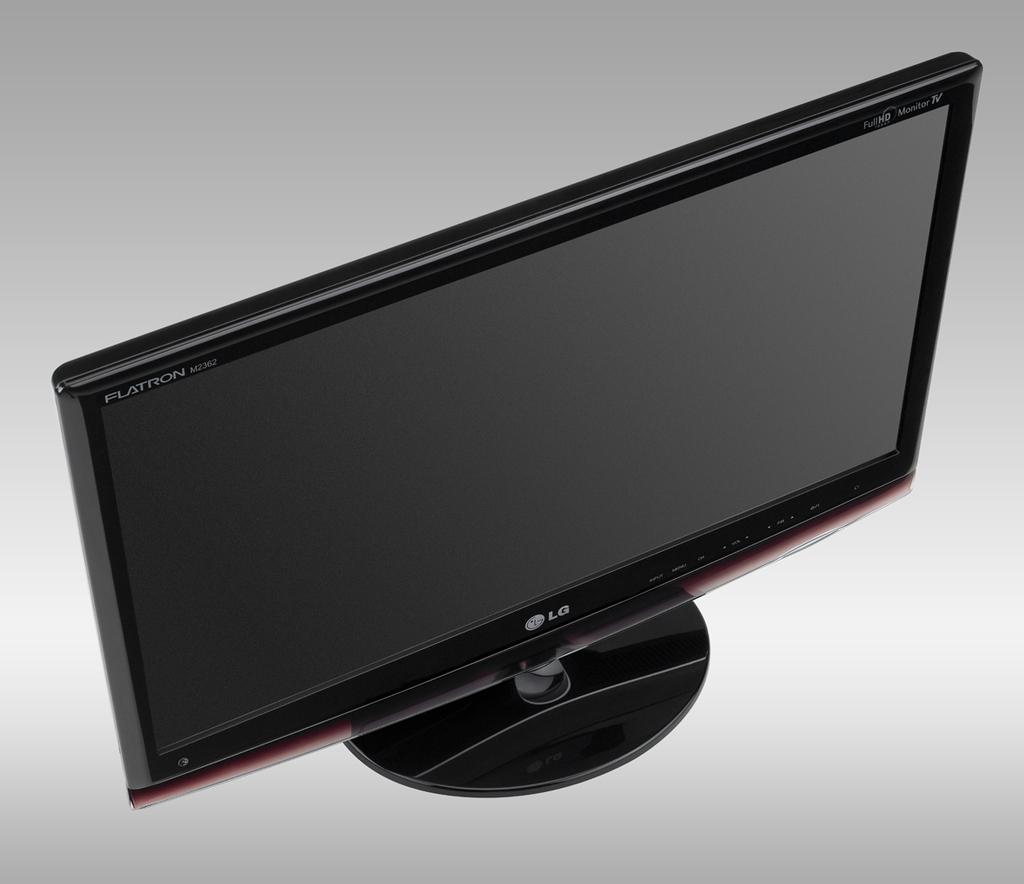What brand of monitor?
Ensure brevity in your answer.  Lg. What does it say at the top of the t.v?
Keep it short and to the point. Flatron. 